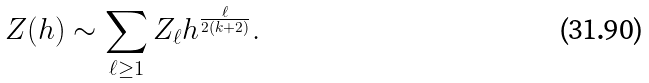<formula> <loc_0><loc_0><loc_500><loc_500>Z ( h ) \sim \sum _ { \ell \geq 1 } Z _ { \ell } h ^ { \frac { \ell } { 2 ( k + 2 ) } } .</formula> 